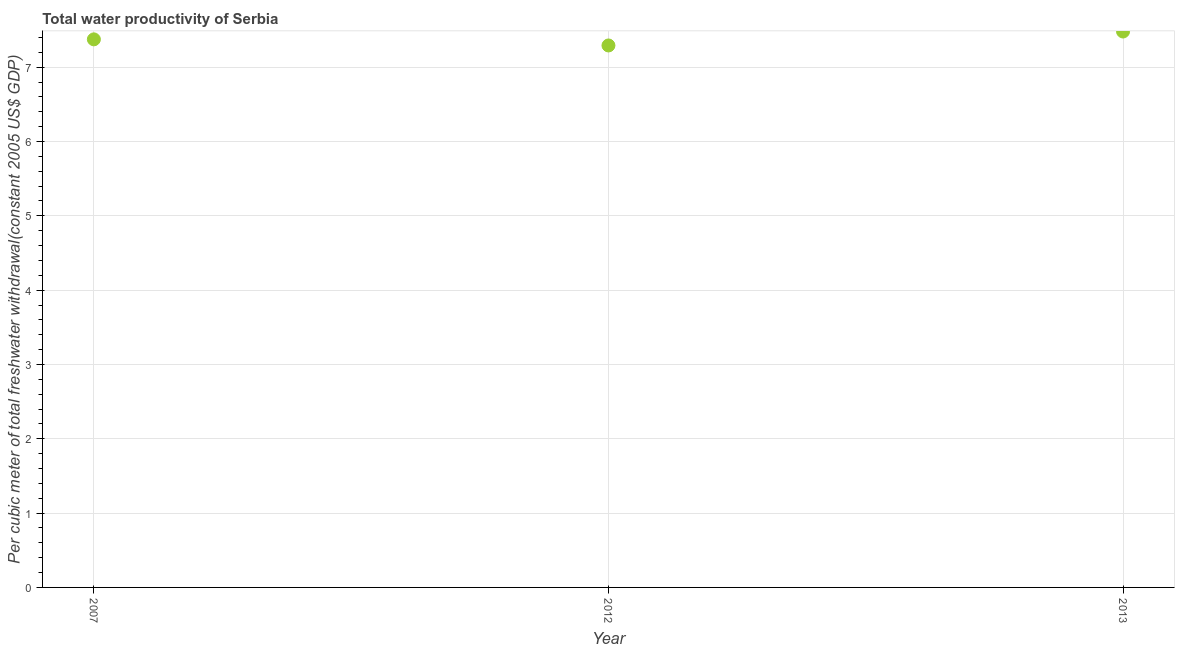What is the total water productivity in 2013?
Keep it short and to the point. 7.48. Across all years, what is the maximum total water productivity?
Provide a short and direct response. 7.48. Across all years, what is the minimum total water productivity?
Your answer should be very brief. 7.29. In which year was the total water productivity maximum?
Offer a very short reply. 2013. In which year was the total water productivity minimum?
Offer a very short reply. 2012. What is the sum of the total water productivity?
Offer a very short reply. 22.15. What is the difference between the total water productivity in 2007 and 2013?
Your response must be concise. -0.11. What is the average total water productivity per year?
Keep it short and to the point. 7.38. What is the median total water productivity?
Offer a terse response. 7.38. Do a majority of the years between 2013 and 2012 (inclusive) have total water productivity greater than 7.2 US$?
Your answer should be very brief. No. What is the ratio of the total water productivity in 2012 to that in 2013?
Your response must be concise. 0.97. Is the total water productivity in 2007 less than that in 2013?
Provide a succinct answer. Yes. What is the difference between the highest and the second highest total water productivity?
Offer a very short reply. 0.11. What is the difference between the highest and the lowest total water productivity?
Make the answer very short. 0.19. How many years are there in the graph?
Your answer should be compact. 3. Are the values on the major ticks of Y-axis written in scientific E-notation?
Give a very brief answer. No. Does the graph contain any zero values?
Provide a succinct answer. No. What is the title of the graph?
Your response must be concise. Total water productivity of Serbia. What is the label or title of the X-axis?
Offer a terse response. Year. What is the label or title of the Y-axis?
Keep it short and to the point. Per cubic meter of total freshwater withdrawal(constant 2005 US$ GDP). What is the Per cubic meter of total freshwater withdrawal(constant 2005 US$ GDP) in 2007?
Your response must be concise. 7.38. What is the Per cubic meter of total freshwater withdrawal(constant 2005 US$ GDP) in 2012?
Ensure brevity in your answer.  7.29. What is the Per cubic meter of total freshwater withdrawal(constant 2005 US$ GDP) in 2013?
Provide a succinct answer. 7.48. What is the difference between the Per cubic meter of total freshwater withdrawal(constant 2005 US$ GDP) in 2007 and 2012?
Ensure brevity in your answer.  0.08. What is the difference between the Per cubic meter of total freshwater withdrawal(constant 2005 US$ GDP) in 2007 and 2013?
Your response must be concise. -0.11. What is the difference between the Per cubic meter of total freshwater withdrawal(constant 2005 US$ GDP) in 2012 and 2013?
Your answer should be very brief. -0.19. 